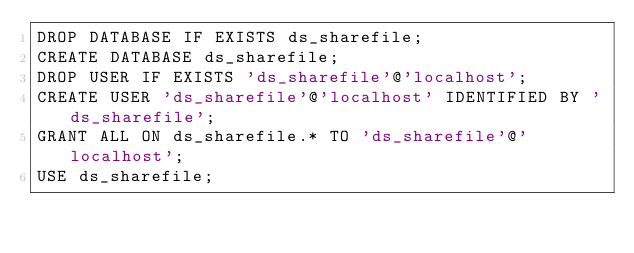Convert code to text. <code><loc_0><loc_0><loc_500><loc_500><_SQL_>DROP DATABASE IF EXISTS ds_sharefile;
CREATE DATABASE ds_sharefile; 
DROP USER IF EXISTS 'ds_sharefile'@'localhost';
CREATE USER 'ds_sharefile'@'localhost' IDENTIFIED BY 'ds_sharefile';
GRANT ALL ON ds_sharefile.* TO 'ds_sharefile'@'localhost';
USE ds_sharefile;
</code> 